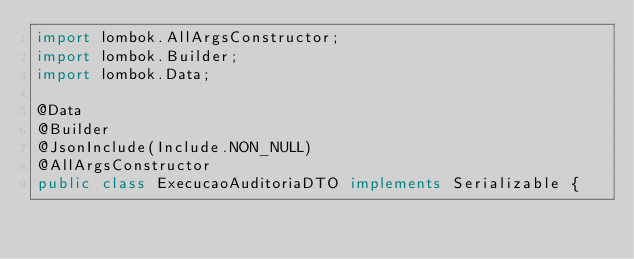<code> <loc_0><loc_0><loc_500><loc_500><_Java_>import lombok.AllArgsConstructor;
import lombok.Builder;
import lombok.Data;

@Data
@Builder
@JsonInclude(Include.NON_NULL)
@AllArgsConstructor
public class ExecucaoAuditoriaDTO implements Serializable {
</code> 